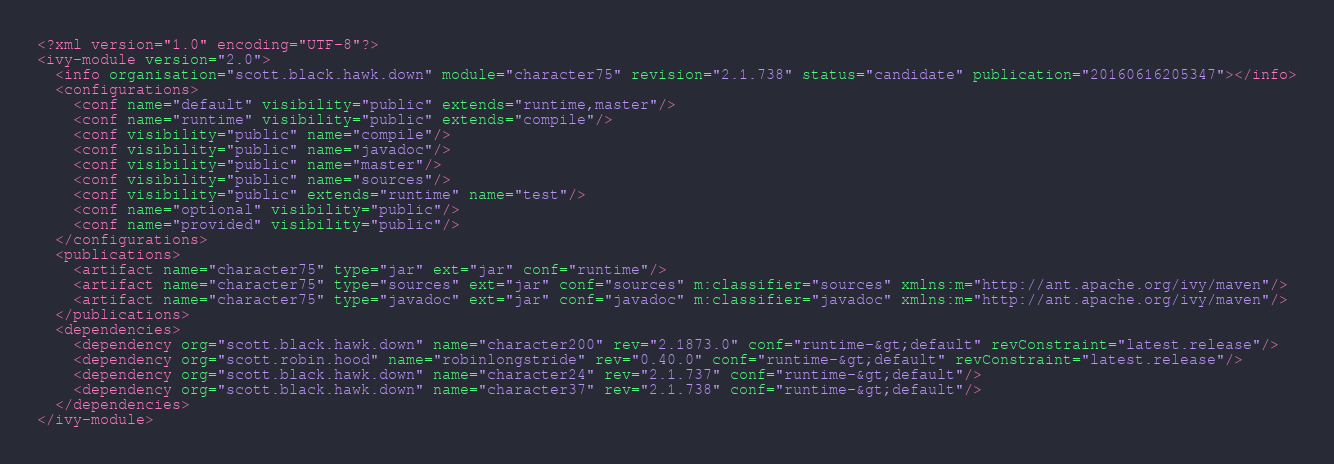<code> <loc_0><loc_0><loc_500><loc_500><_XML_><?xml version="1.0" encoding="UTF-8"?>
<ivy-module version="2.0">
  <info organisation="scott.black.hawk.down" module="character75" revision="2.1.738" status="candidate" publication="20160616205347"></info>
  <configurations>
    <conf name="default" visibility="public" extends="runtime,master"/>
    <conf name="runtime" visibility="public" extends="compile"/>
    <conf visibility="public" name="compile"/>
    <conf visibility="public" name="javadoc"/>
    <conf visibility="public" name="master"/>
    <conf visibility="public" name="sources"/>
    <conf visibility="public" extends="runtime" name="test"/>
    <conf name="optional" visibility="public"/>
    <conf name="provided" visibility="public"/>
  </configurations>
  <publications>
    <artifact name="character75" type="jar" ext="jar" conf="runtime"/>
    <artifact name="character75" type="sources" ext="jar" conf="sources" m:classifier="sources" xmlns:m="http://ant.apache.org/ivy/maven"/>
    <artifact name="character75" type="javadoc" ext="jar" conf="javadoc" m:classifier="javadoc" xmlns:m="http://ant.apache.org/ivy/maven"/>
  </publications>
  <dependencies>
    <dependency org="scott.black.hawk.down" name="character200" rev="2.1873.0" conf="runtime-&gt;default" revConstraint="latest.release"/>
    <dependency org="scott.robin.hood" name="robinlongstride" rev="0.40.0" conf="runtime-&gt;default" revConstraint="latest.release"/>
    <dependency org="scott.black.hawk.down" name="character24" rev="2.1.737" conf="runtime-&gt;default"/>
    <dependency org="scott.black.hawk.down" name="character37" rev="2.1.738" conf="runtime-&gt;default"/>
  </dependencies>
</ivy-module>
</code> 